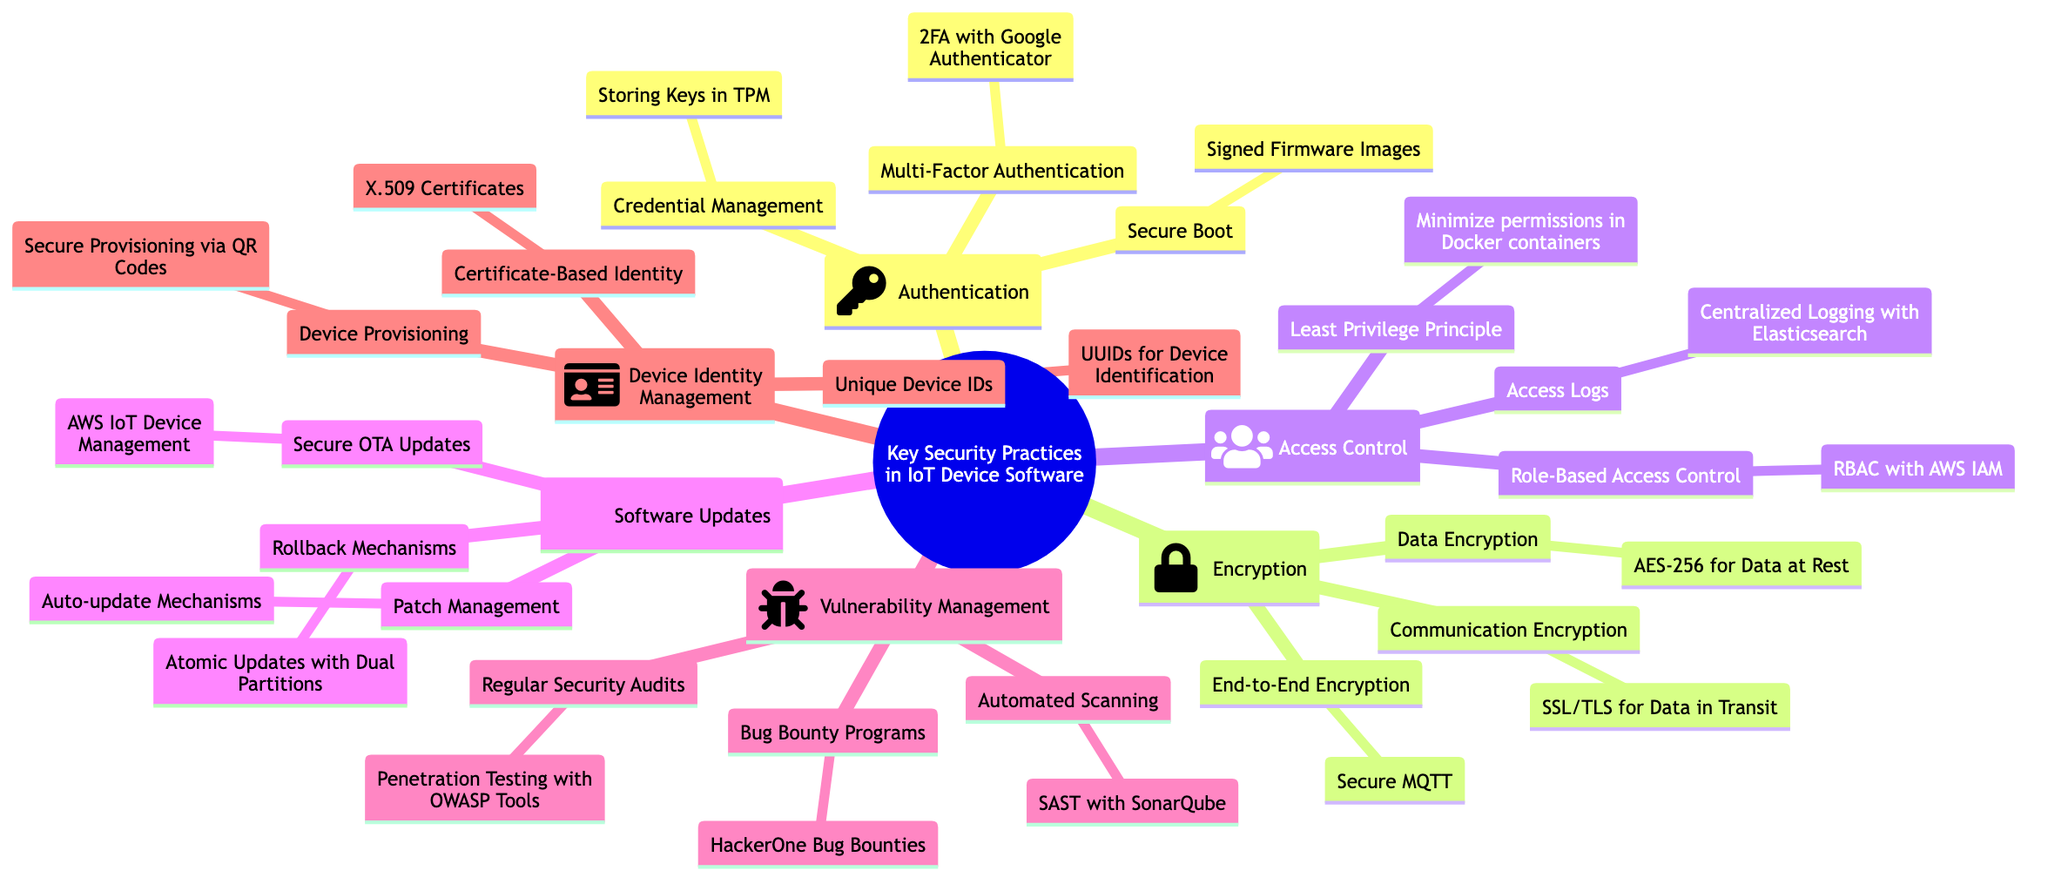What is the main topic of the mind map? The main topic node at the center of the diagram states "Key Security Practices in IoT Device Software." Therefore, that is the answer.
Answer: Key Security Practices in IoT Device Software How many subtopics are there in the mind map? The mind map includes six subtopics branching from the main topic: Authentication, Encryption, Access Control, Software Updates, Vulnerability Management, and Device Identity Management. Summing these gives a total of six.
Answer: 6 What is an example of Multi-Factor Authentication? Under the Authentication subtopic, it explicitly mentions "2FA with Google Authenticator" as an example of Multi-Factor Authentication.
Answer: 2FA with Google Authenticator Which subtopic includes the example "AWS IoT Device Management"? This example is found under the "Software Updates" subtopic, indicating a focus on secure OTA updates.
Answer: Software Updates What security practice involves "Centralized Logging with Elasticsearch"? The example "Centralized Logging with Elasticsearch" is related to the Access Control subtopic, specifically highlighting the importance of access logs.
Answer: Access Control What principle is highlighted under Access Control alongside "Minimize permissions in Docker containers"? The "Least Privilege Principle" is noted directly alongside "Minimize permissions in Docker containers" under the Access Control subtopic.
Answer: Least Privilege Principle Which subtopic is related to "HackerOne Bug Bounties"? The "Bug Bounty Programs" example is situated under the Vulnerability Management subtopic, indicating its association with vulnerability assessment practices.
Answer: Vulnerability Management What does the Device Identity Management subtopic suggest about device identification? The Device Identity Management subtopic includes the example "UUIDs for Device Identification," emphasizing the need for unique identifiers for devices.
Answer: UUIDs for Device Identification How many elements are listed under the Encryption subtopic? There are three elements listed under the Encryption subtopic: Data Encryption, Communication Encryption, and End-to-End Encryption, totaling three elements.
Answer: 3 